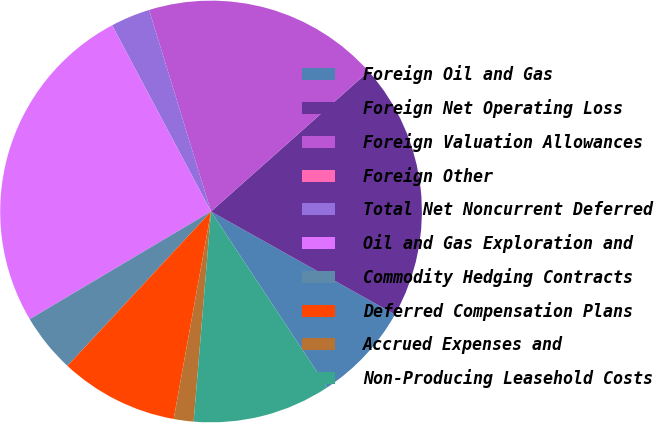Convert chart to OTSL. <chart><loc_0><loc_0><loc_500><loc_500><pie_chart><fcel>Foreign Oil and Gas<fcel>Foreign Net Operating Loss<fcel>Foreign Valuation Allowances<fcel>Foreign Other<fcel>Total Net Noncurrent Deferred<fcel>Oil and Gas Exploration and<fcel>Commodity Hedging Contracts<fcel>Deferred Compensation Plans<fcel>Accrued Expenses and<fcel>Non-Producing Leasehold Costs<nl><fcel>7.58%<fcel>19.7%<fcel>18.18%<fcel>0.0%<fcel>3.03%<fcel>25.76%<fcel>4.55%<fcel>9.09%<fcel>1.52%<fcel>10.61%<nl></chart> 